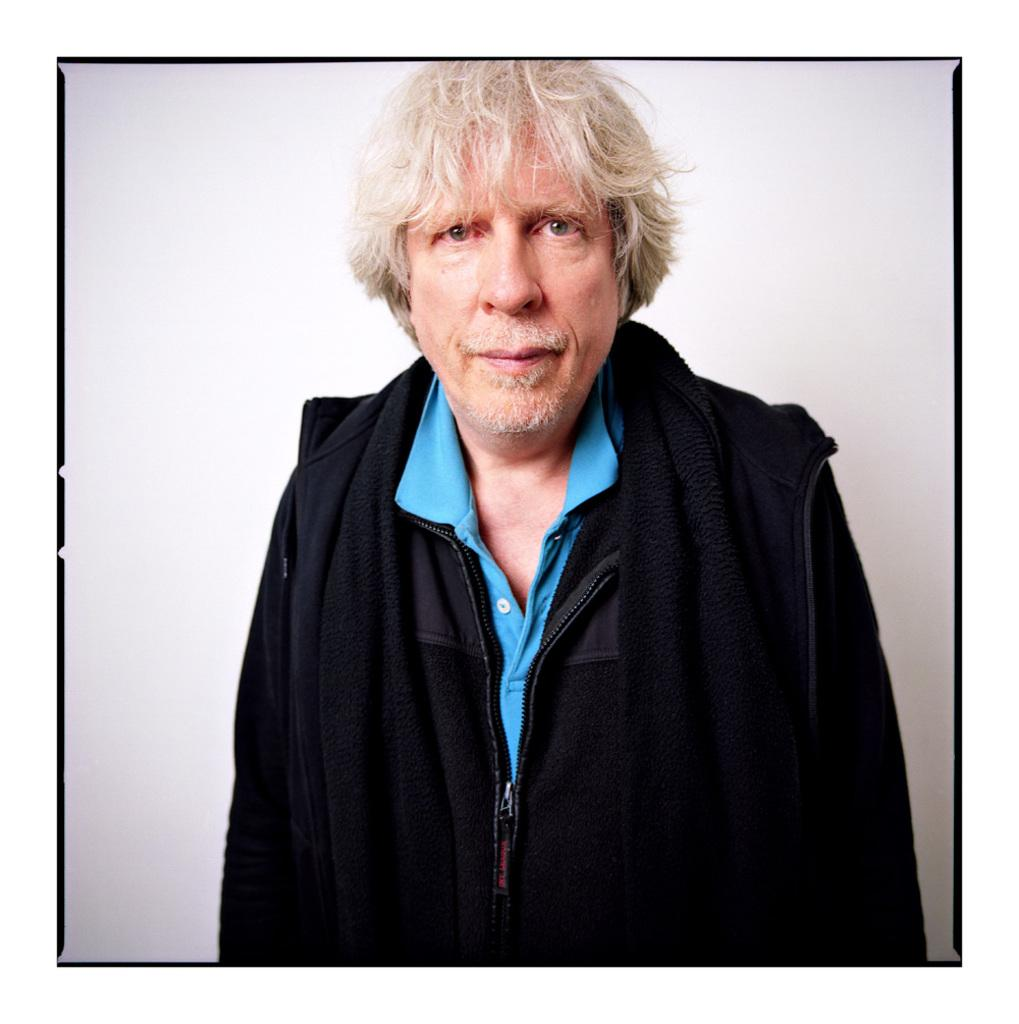What is the main subject of the image? There is a man standing in the image. What is the man wearing in the image? The man is wearing a jacket. What color is the background of the image? The background of the image is white. What type of growth can be seen on the boat in the image? There is no boat present in the image, and therefore no growth can be observed. 